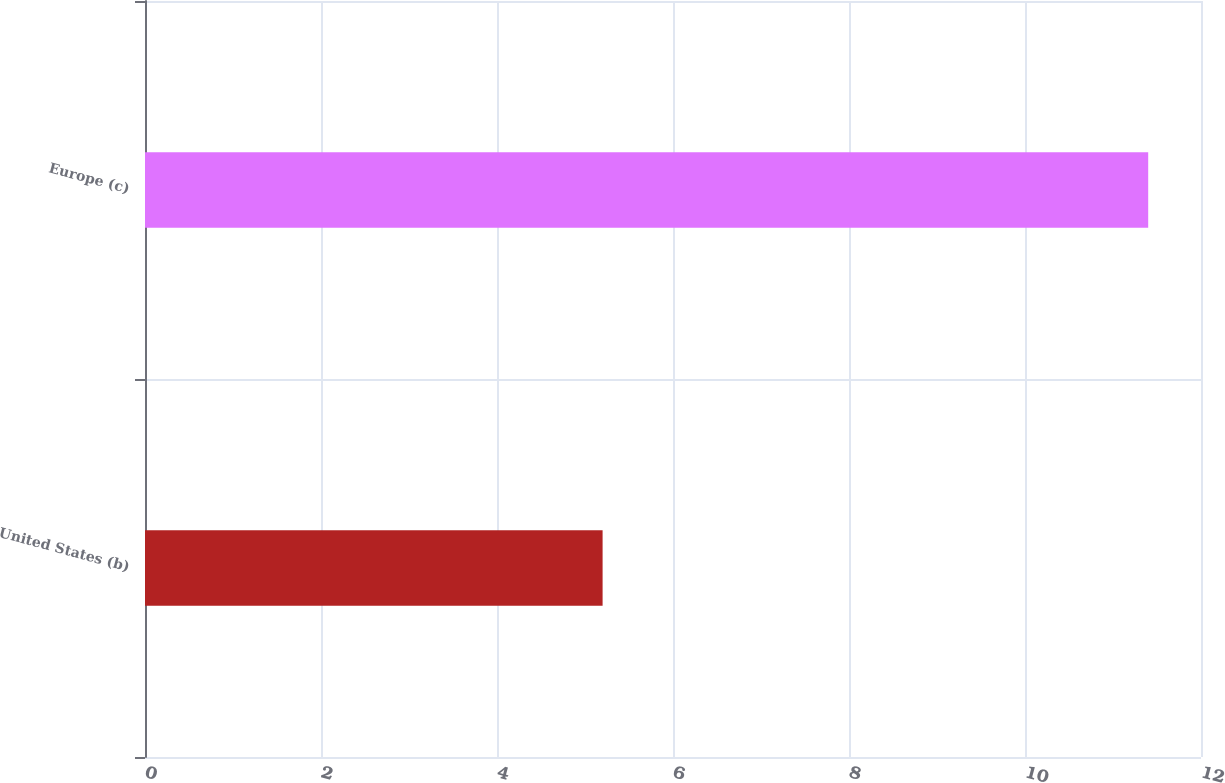<chart> <loc_0><loc_0><loc_500><loc_500><bar_chart><fcel>United States (b)<fcel>Europe (c)<nl><fcel>5.2<fcel>11.4<nl></chart> 